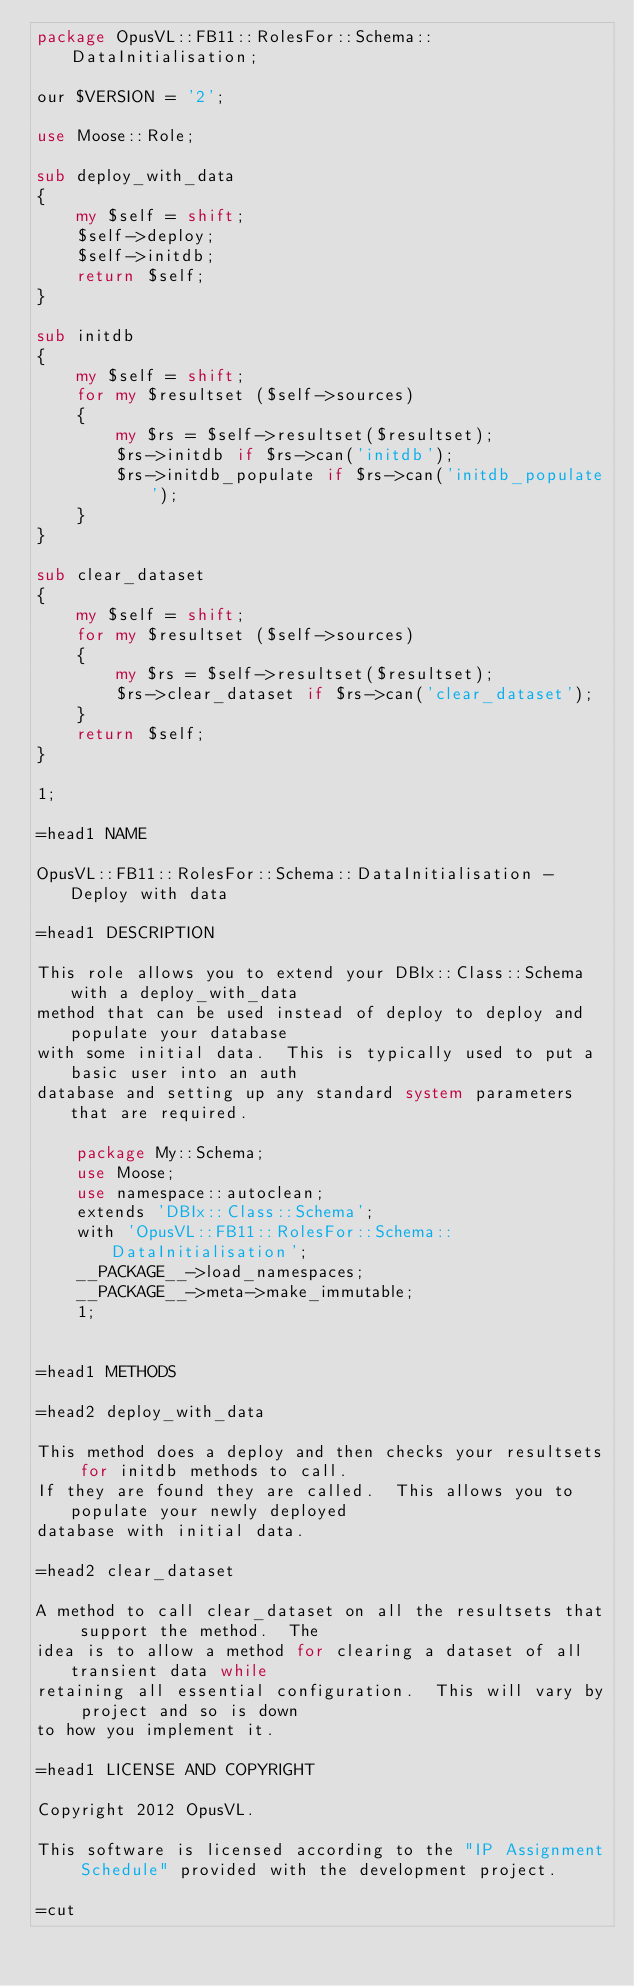<code> <loc_0><loc_0><loc_500><loc_500><_Perl_>package OpusVL::FB11::RolesFor::Schema::DataInitialisation;

our $VERSION = '2';

use Moose::Role;

sub deploy_with_data
{
    my $self = shift;
    $self->deploy;
    $self->initdb;
    return $self;
}

sub initdb
{
    my $self = shift;
    for my $resultset ($self->sources)
    {
        my $rs = $self->resultset($resultset);
        $rs->initdb if $rs->can('initdb');
        $rs->initdb_populate if $rs->can('initdb_populate');
    }
}

sub clear_dataset
{
    my $self = shift;
    for my $resultset ($self->sources)
    {
        my $rs = $self->resultset($resultset);
        $rs->clear_dataset if $rs->can('clear_dataset');
    }
    return $self;
}

1;

=head1 NAME

OpusVL::FB11::RolesFor::Schema::DataInitialisation - Deploy with data

=head1 DESCRIPTION

This role allows you to extend your DBIx::Class::Schema with a deploy_with_data
method that can be used instead of deploy to deploy and populate your database
with some initial data.  This is typically used to put a basic user into an auth
database and setting up any standard system parameters that are required.

    package My::Schema;
    use Moose;
    use namespace::autoclean;
    extends 'DBIx::Class::Schema';
    with 'OpusVL::FB11::RolesFor::Schema::DataInitialisation';
    __PACKAGE__->load_namespaces;
    __PACKAGE__->meta->make_immutable;
    1;


=head1 METHODS

=head2 deploy_with_data

This method does a deploy and then checks your resultsets for initdb methods to call.
If they are found they are called.  This allows you to populate your newly deployed
database with initial data.

=head2 clear_dataset

A method to call clear_dataset on all the resultsets that support the method.  The
idea is to allow a method for clearing a dataset of all transient data while
retaining all essential configuration.  This will vary by project and so is down
to how you implement it.

=head1 LICENSE AND COPYRIGHT

Copyright 2012 OpusVL.

This software is licensed according to the "IP Assignment Schedule" provided with the development project.

=cut
</code> 